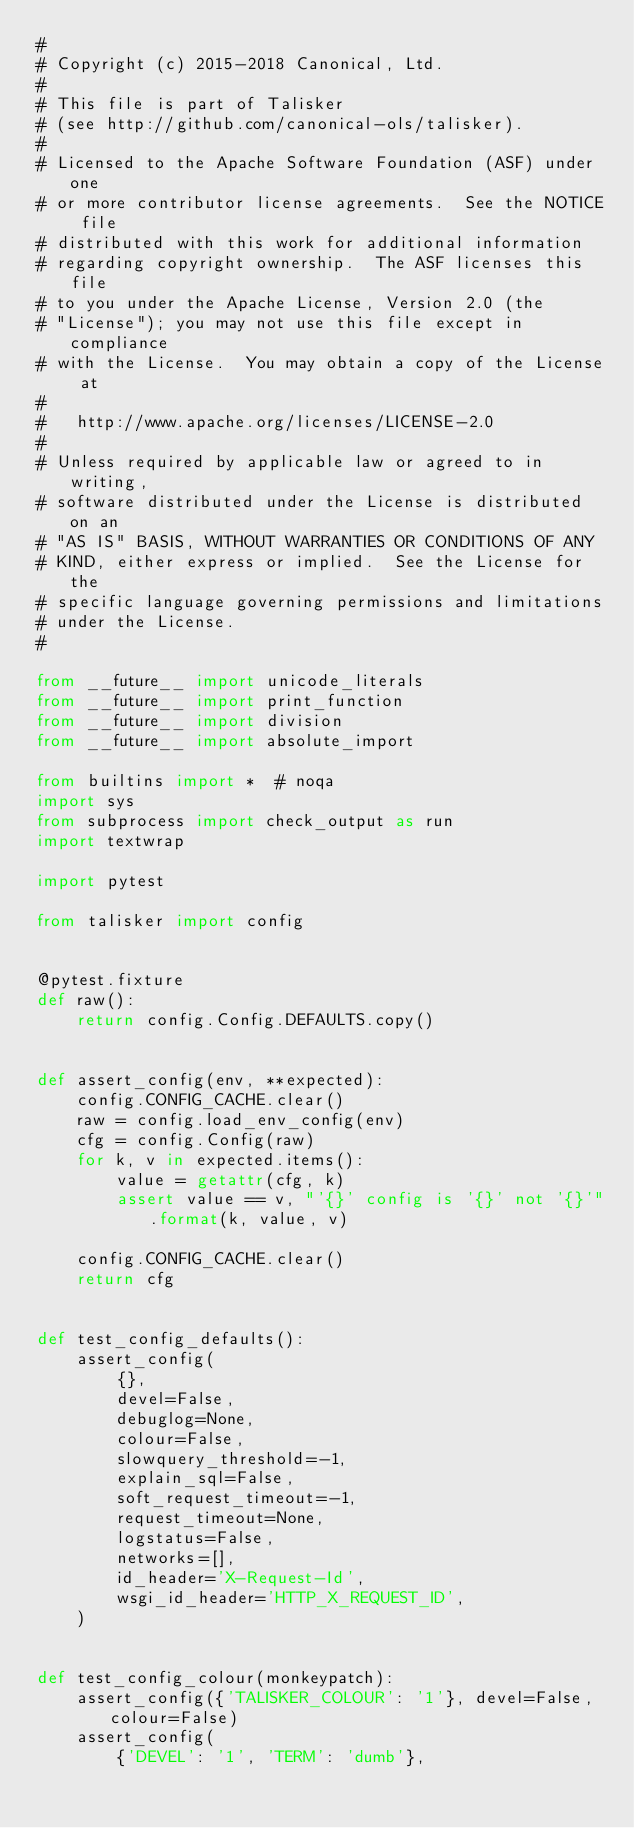Convert code to text. <code><loc_0><loc_0><loc_500><loc_500><_Python_>#
# Copyright (c) 2015-2018 Canonical, Ltd.
#
# This file is part of Talisker
# (see http://github.com/canonical-ols/talisker).
#
# Licensed to the Apache Software Foundation (ASF) under one
# or more contributor license agreements.  See the NOTICE file
# distributed with this work for additional information
# regarding copyright ownership.  The ASF licenses this file
# to you under the Apache License, Version 2.0 (the
# "License"); you may not use this file except in compliance
# with the License.  You may obtain a copy of the License at
#
#   http://www.apache.org/licenses/LICENSE-2.0
#
# Unless required by applicable law or agreed to in writing,
# software distributed under the License is distributed on an
# "AS IS" BASIS, WITHOUT WARRANTIES OR CONDITIONS OF ANY
# KIND, either express or implied.  See the License for the
# specific language governing permissions and limitations
# under the License.
#

from __future__ import unicode_literals
from __future__ import print_function
from __future__ import division
from __future__ import absolute_import

from builtins import *  # noqa
import sys
from subprocess import check_output as run
import textwrap

import pytest

from talisker import config


@pytest.fixture
def raw():
    return config.Config.DEFAULTS.copy()


def assert_config(env, **expected):
    config.CONFIG_CACHE.clear()
    raw = config.load_env_config(env)
    cfg = config.Config(raw)
    for k, v in expected.items():
        value = getattr(cfg, k)
        assert value == v, "'{}' config is '{}' not '{}'".format(k, value, v)

    config.CONFIG_CACHE.clear()
    return cfg


def test_config_defaults():
    assert_config(
        {},
        devel=False,
        debuglog=None,
        colour=False,
        slowquery_threshold=-1,
        explain_sql=False,
        soft_request_timeout=-1,
        request_timeout=None,
        logstatus=False,
        networks=[],
        id_header='X-Request-Id',
        wsgi_id_header='HTTP_X_REQUEST_ID',
    )


def test_config_colour(monkeypatch):
    assert_config({'TALISKER_COLOUR': '1'}, devel=False, colour=False)
    assert_config(
        {'DEVEL': '1', 'TERM': 'dumb'},</code> 